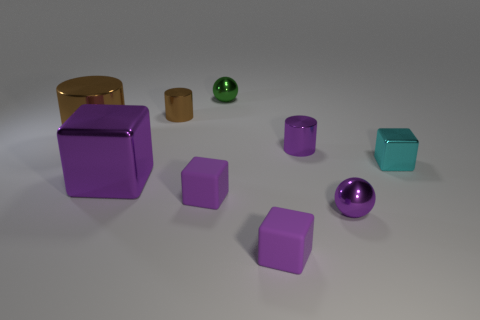What shape is the tiny metallic object that is the same color as the big cylinder?
Your response must be concise. Cylinder. The tiny thing that is right of the green metal object and behind the small cyan object is made of what material?
Keep it short and to the point. Metal. Are there fewer tiny brown metallic cylinders than purple cubes?
Give a very brief answer. Yes. There is a small green object; is it the same shape as the large thing that is in front of the big shiny cylinder?
Provide a short and direct response. No. There is a metallic cylinder to the right of the green shiny sphere; is its size the same as the cyan shiny block?
Offer a terse response. Yes. The brown metal object that is the same size as the green object is what shape?
Your answer should be very brief. Cylinder. Do the big purple metallic thing and the cyan object have the same shape?
Your response must be concise. Yes. How many purple metallic objects are the same shape as the cyan shiny object?
Ensure brevity in your answer.  1. What number of large metal things are in front of the big brown cylinder?
Your response must be concise. 1. Do the small ball in front of the purple metallic cube and the large metallic block have the same color?
Your answer should be compact. Yes. 